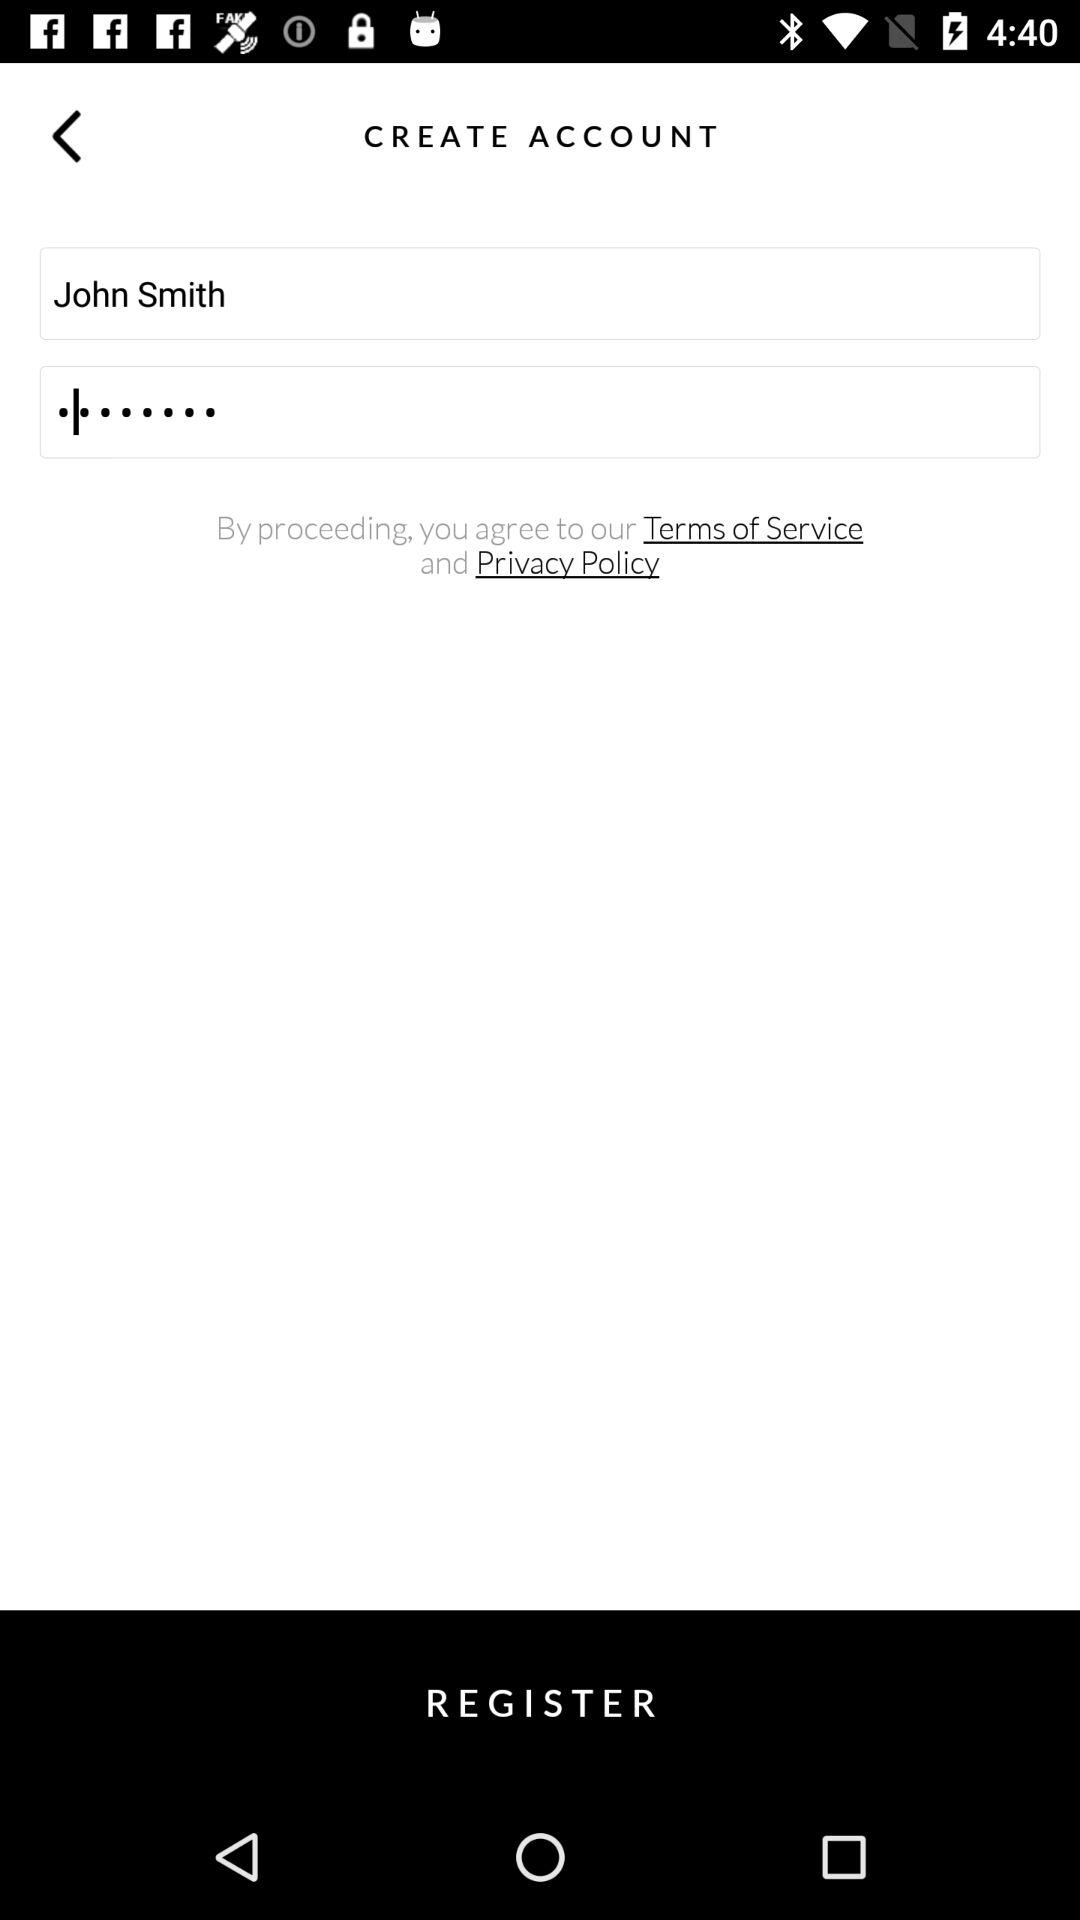What's the user name? The user name is "John Smith". 